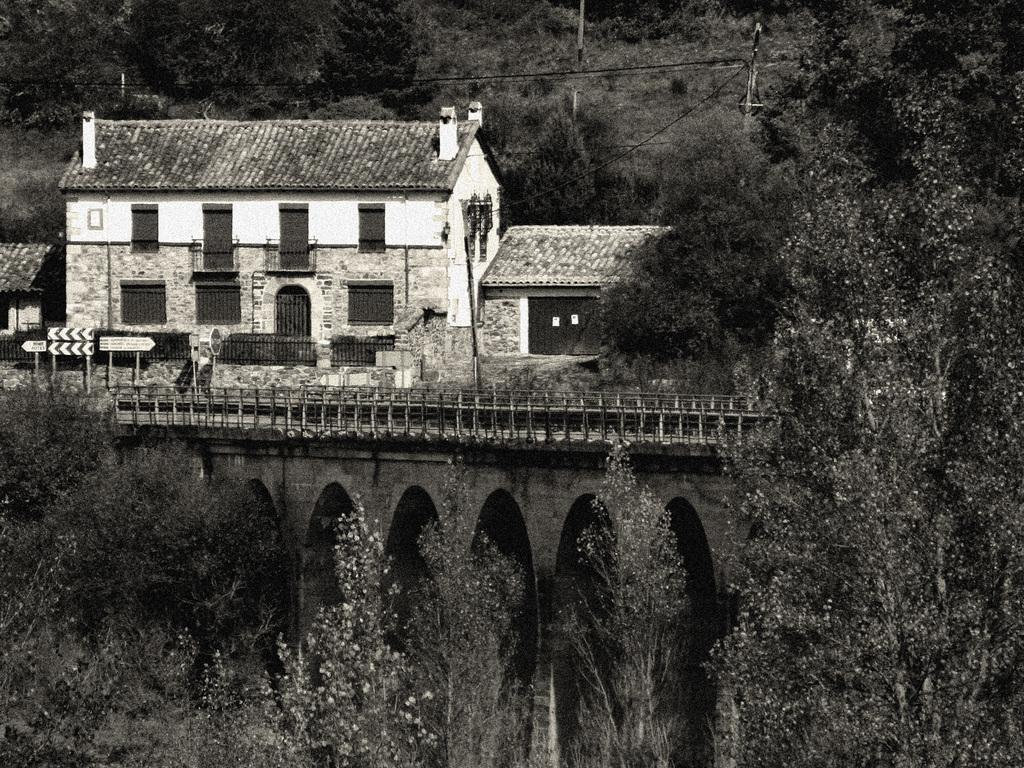What type of picture is in the image? The image contains a black and white picture. What natural elements can be seen in the image? There are trees in the image. What man-made structure is present in the image? There is a bridge in the image. What feature of the bridge is visible? The railing is visible in the image. What type of signage is present in the image? There are sign boards in the image. What type of building can be seen in the background of the image? There is a building in the background of the image. What other man-made structures are visible in the background of the image? There are poles in the background of the image. Are there any additional natural elements visible in the background of the image? Yes, there are additional trees in the background of the image. What language is spoken by the trees in the image? Trees do not speak any language, so this question cannot be answered. 